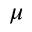<formula> <loc_0><loc_0><loc_500><loc_500>\mu</formula> 